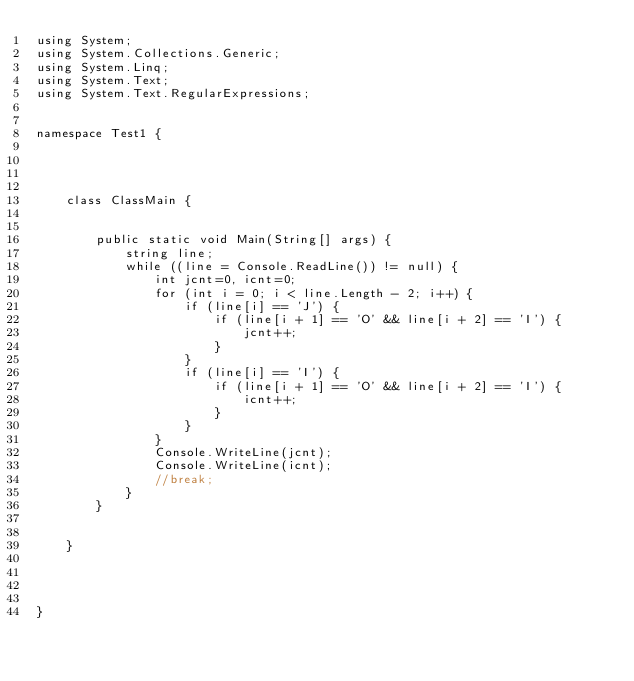<code> <loc_0><loc_0><loc_500><loc_500><_C#_>using System;
using System.Collections.Generic;
using System.Linq;
using System.Text;
using System.Text.RegularExpressions;


namespace Test1 {

    


    class ClassMain {

       
        public static void Main(String[] args) {
            string line;
            while ((line = Console.ReadLine()) != null) {
                int jcnt=0, icnt=0;
                for (int i = 0; i < line.Length - 2; i++) {
                    if (line[i] == 'J') {
                        if (line[i + 1] == 'O' && line[i + 2] == 'I') {
                            jcnt++;
                        }
                    }
                    if (line[i] == 'I') {
                        if (line[i + 1] == 'O' && line[i + 2] == 'I') {
                            icnt++;
                        }
                    }
                }
                Console.WriteLine(jcnt);
                Console.WriteLine(icnt);
                //break;
            }
        }

        
    }



    
}</code> 